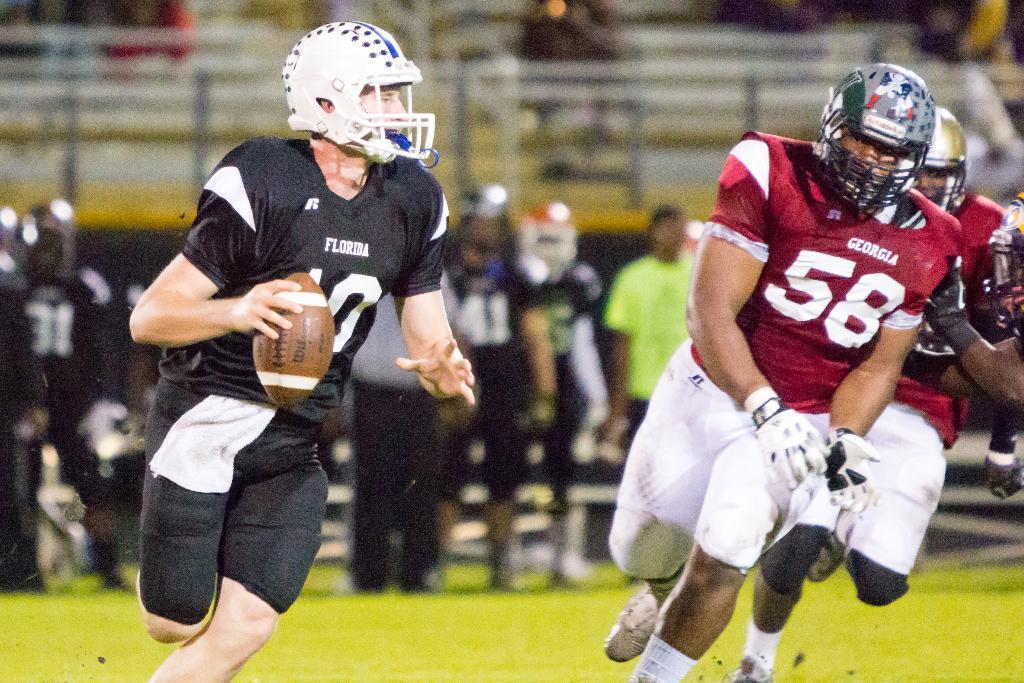How would you summarize this image in a sentence or two? In this picture there are three people running on the ground. Towards the left there is a person, he is wearing a black t shirt, black shorts and holding a ball. Towards the right there are two persons, first person is wearing a red t shirt and white shorts and wearing a helmet behind him there is another person, he is wearing a red t shirt and white shorts. In the background there are group of people and a fence. 